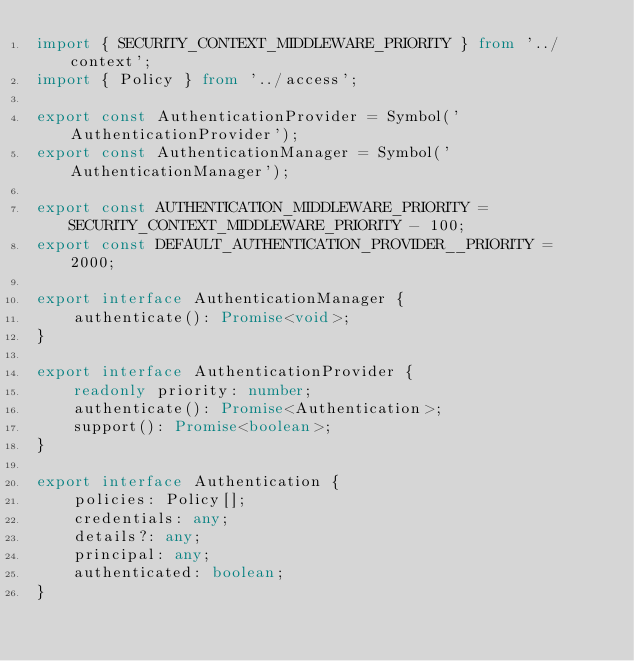<code> <loc_0><loc_0><loc_500><loc_500><_TypeScript_>import { SECURITY_CONTEXT_MIDDLEWARE_PRIORITY } from '../context';
import { Policy } from '../access';

export const AuthenticationProvider = Symbol('AuthenticationProvider');
export const AuthenticationManager = Symbol('AuthenticationManager');

export const AUTHENTICATION_MIDDLEWARE_PRIORITY = SECURITY_CONTEXT_MIDDLEWARE_PRIORITY - 100;
export const DEFAULT_AUTHENTICATION_PROVIDER__PRIORITY =  2000;

export interface AuthenticationManager {
    authenticate(): Promise<void>;
}

export interface AuthenticationProvider {
    readonly priority: number;
    authenticate(): Promise<Authentication>;
    support(): Promise<boolean>;
}

export interface Authentication {
    policies: Policy[];
    credentials: any;
    details?: any;
    principal: any;
    authenticated: boolean;
}
</code> 